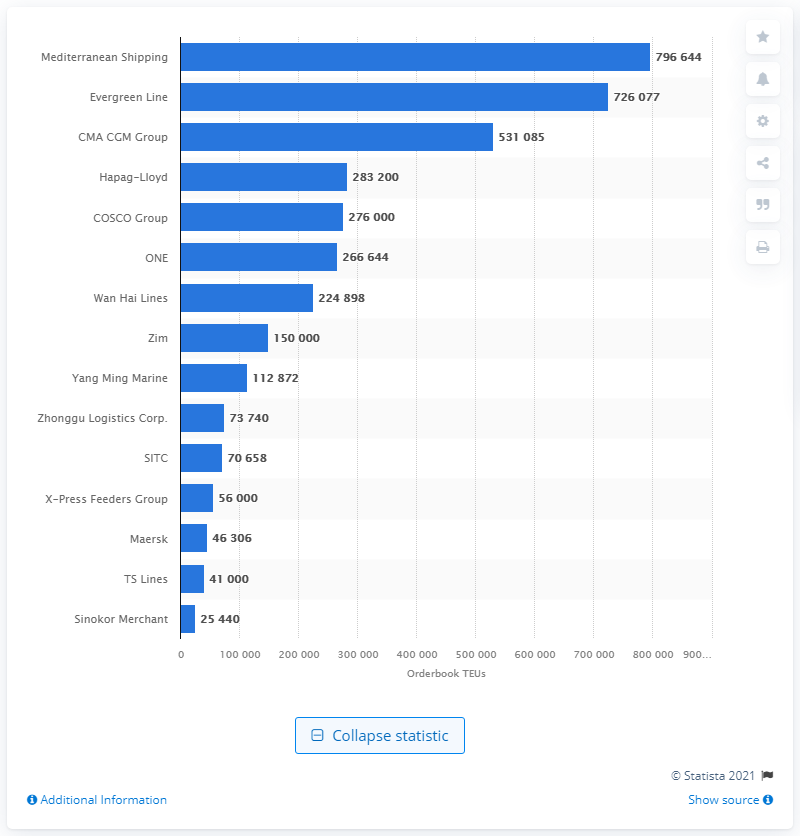Give some essential details in this illustration. The second-ranked company in terms of order book capacity is Evergreen Line. 